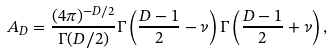<formula> <loc_0><loc_0><loc_500><loc_500>A _ { D } = \frac { ( 4 \pi ) ^ { - D / 2 } } { \Gamma ( D / 2 ) } \Gamma \left ( \frac { D - 1 } { 2 } - \nu \right ) \Gamma \left ( \frac { D - 1 } { 2 } + \nu \right ) ,</formula> 